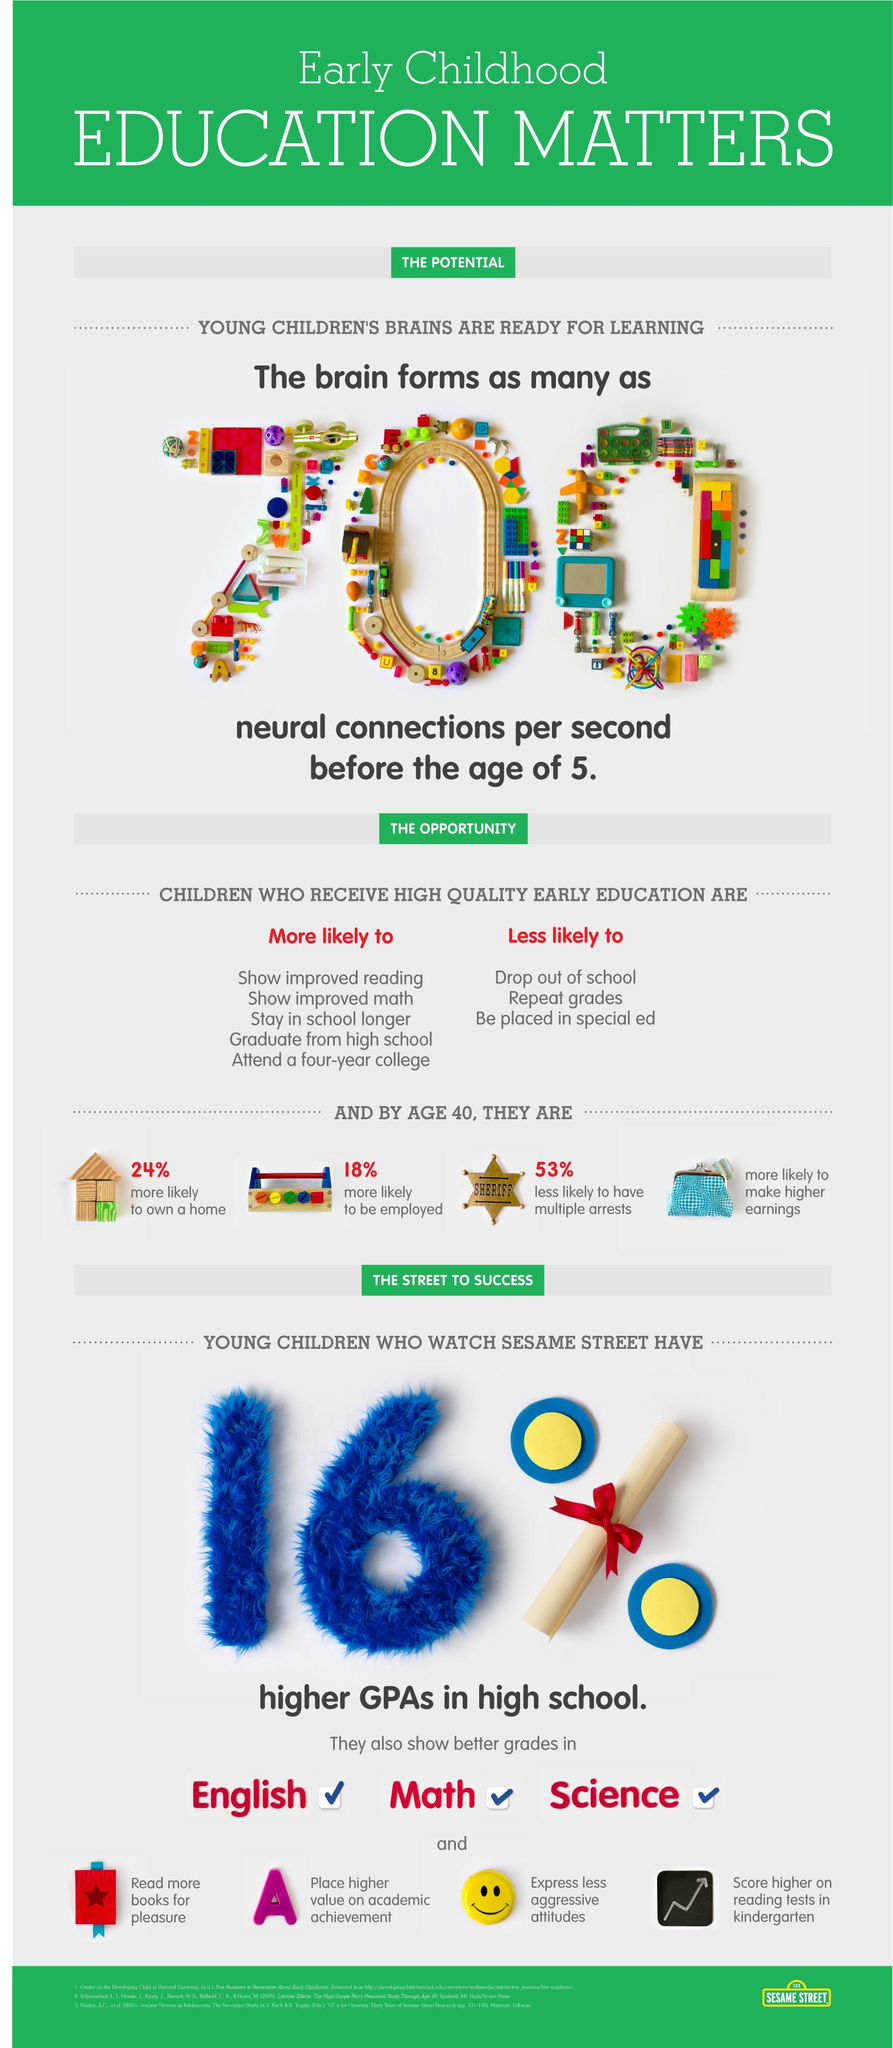Give some essential details in this illustration. The infographic contains 3 subjects. 